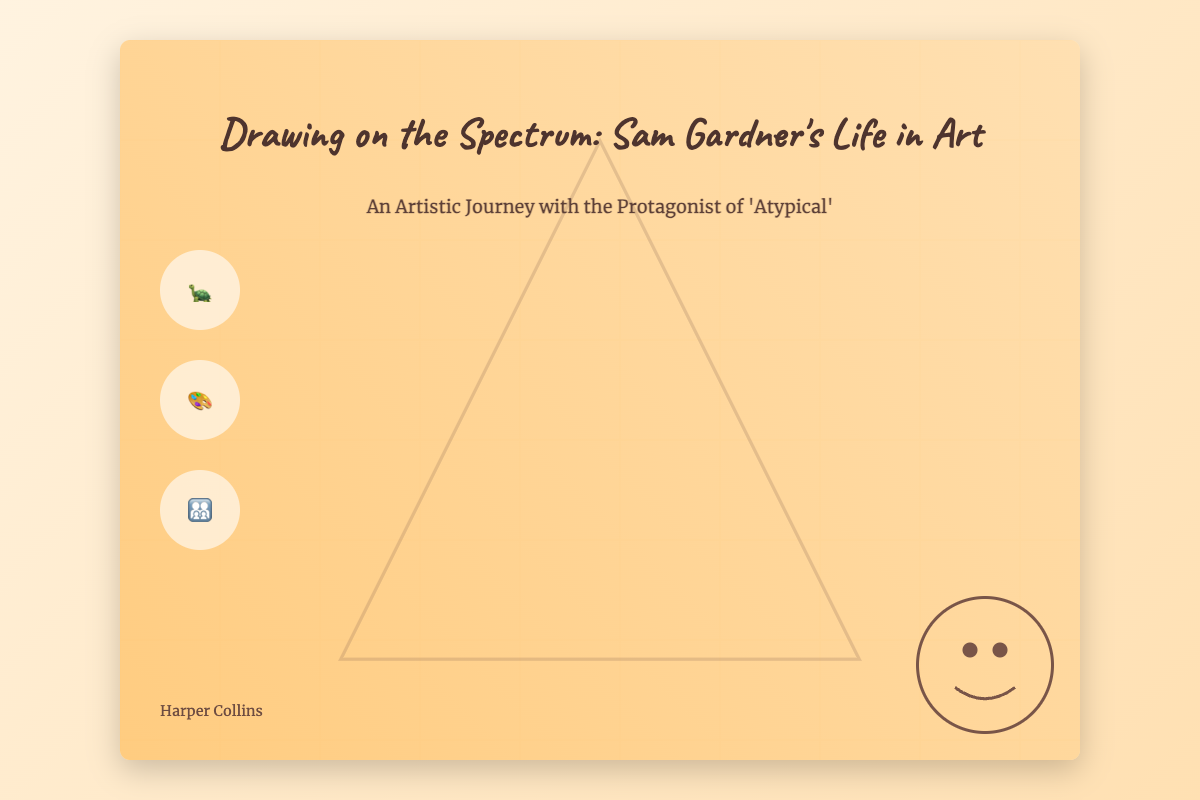What is the title of the book? The title of the book is prominently displayed at the top of the cover in a large font.
Answer: Drawing on the Spectrum: Sam Gardner's Life in Art Who is the author of the book? The author's name is located at the bottom of the book cover.
Answer: Harper Collins What type of scenes are depicted on the cover? The cover includes small icons representing scenes, which hint at different aspects of Sam's life.
Answer: Turtle, Paint Palette, Family What color is the book's background? The background features a gradient of warm colors that create an inviting atmosphere.
Answer: Warm colors What is the subtitle of the book? The subtitle is located just below the title and provides additional context about the book.
Answer: An Artistic Journey with the Protagonist of 'Atypical' 